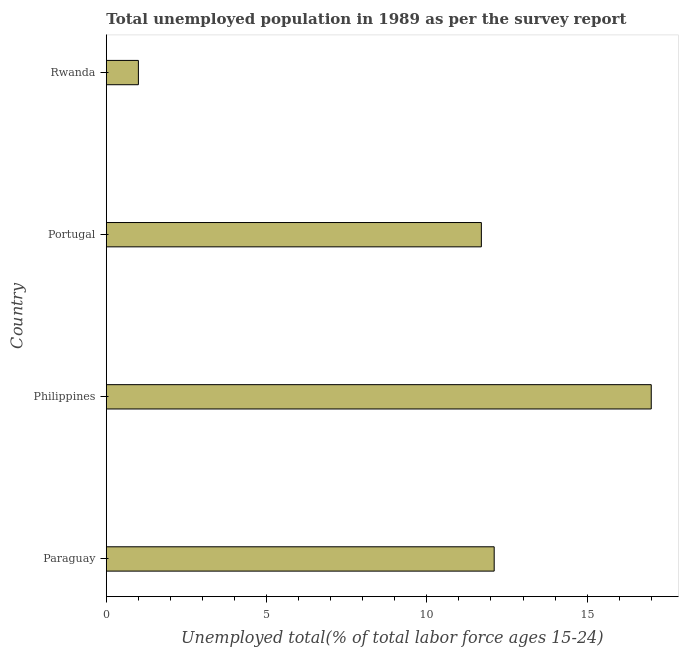Does the graph contain grids?
Give a very brief answer. No. What is the title of the graph?
Ensure brevity in your answer.  Total unemployed population in 1989 as per the survey report. What is the label or title of the X-axis?
Your answer should be very brief. Unemployed total(% of total labor force ages 15-24). What is the label or title of the Y-axis?
Ensure brevity in your answer.  Country. Across all countries, what is the maximum unemployed youth?
Provide a succinct answer. 17. In which country was the unemployed youth maximum?
Provide a succinct answer. Philippines. In which country was the unemployed youth minimum?
Offer a very short reply. Rwanda. What is the sum of the unemployed youth?
Ensure brevity in your answer.  41.8. What is the difference between the unemployed youth in Paraguay and Philippines?
Ensure brevity in your answer.  -4.9. What is the average unemployed youth per country?
Your answer should be very brief. 10.45. What is the median unemployed youth?
Give a very brief answer. 11.9. In how many countries, is the unemployed youth greater than 14 %?
Keep it short and to the point. 1. Is the unemployed youth in Paraguay less than that in Rwanda?
Provide a short and direct response. No. Is the difference between the unemployed youth in Paraguay and Philippines greater than the difference between any two countries?
Your answer should be very brief. No. What is the difference between the highest and the lowest unemployed youth?
Make the answer very short. 16. How many bars are there?
Ensure brevity in your answer.  4. Are all the bars in the graph horizontal?
Make the answer very short. Yes. How many countries are there in the graph?
Keep it short and to the point. 4. Are the values on the major ticks of X-axis written in scientific E-notation?
Offer a very short reply. No. What is the Unemployed total(% of total labor force ages 15-24) of Paraguay?
Ensure brevity in your answer.  12.1. What is the Unemployed total(% of total labor force ages 15-24) of Philippines?
Ensure brevity in your answer.  17. What is the Unemployed total(% of total labor force ages 15-24) in Portugal?
Give a very brief answer. 11.7. What is the Unemployed total(% of total labor force ages 15-24) of Rwanda?
Your answer should be compact. 1. What is the difference between the Unemployed total(% of total labor force ages 15-24) in Paraguay and Philippines?
Offer a terse response. -4.9. What is the difference between the Unemployed total(% of total labor force ages 15-24) in Philippines and Rwanda?
Provide a short and direct response. 16. What is the ratio of the Unemployed total(% of total labor force ages 15-24) in Paraguay to that in Philippines?
Provide a succinct answer. 0.71. What is the ratio of the Unemployed total(% of total labor force ages 15-24) in Paraguay to that in Portugal?
Keep it short and to the point. 1.03. What is the ratio of the Unemployed total(% of total labor force ages 15-24) in Paraguay to that in Rwanda?
Your answer should be compact. 12.1. What is the ratio of the Unemployed total(% of total labor force ages 15-24) in Philippines to that in Portugal?
Keep it short and to the point. 1.45. What is the ratio of the Unemployed total(% of total labor force ages 15-24) in Philippines to that in Rwanda?
Ensure brevity in your answer.  17. 